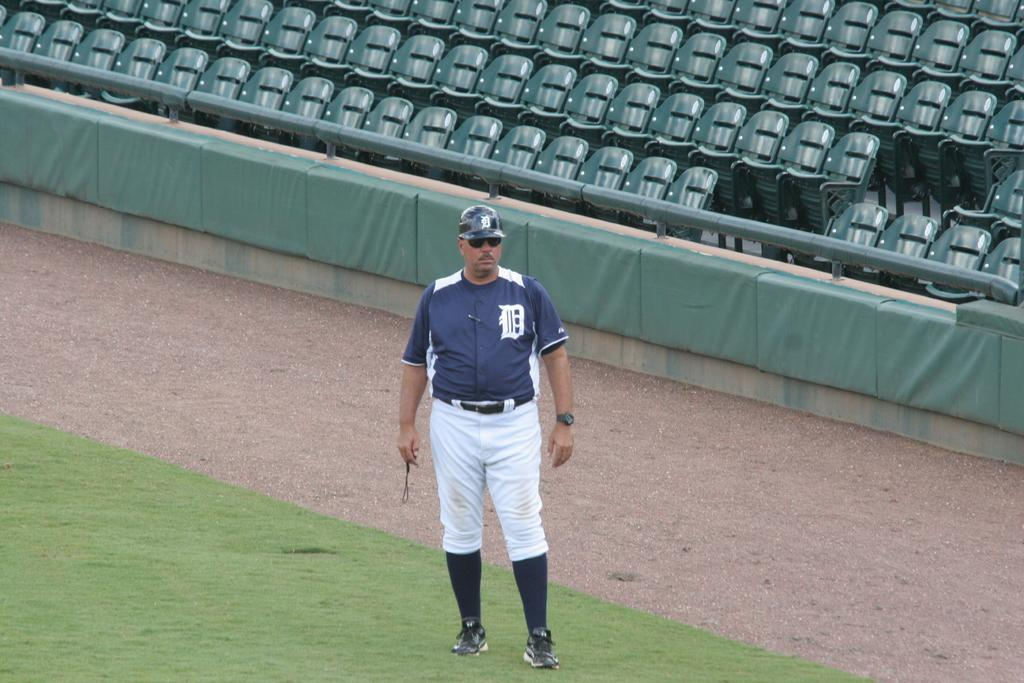Who is present in the image? There is a man in the image. What is the man standing on? The man is standing on a green surface. What accessories is the man wearing? The man is wearing a cap and glasses. What can be seen in the background of the image? There are chairs and a rod in the background of the image. What is the caption of the image? There is no caption present in the image. What activity is the man engaged in within the image? The provided facts do not specify any activity the man is engaged in; he is simply standing on a green surface. 